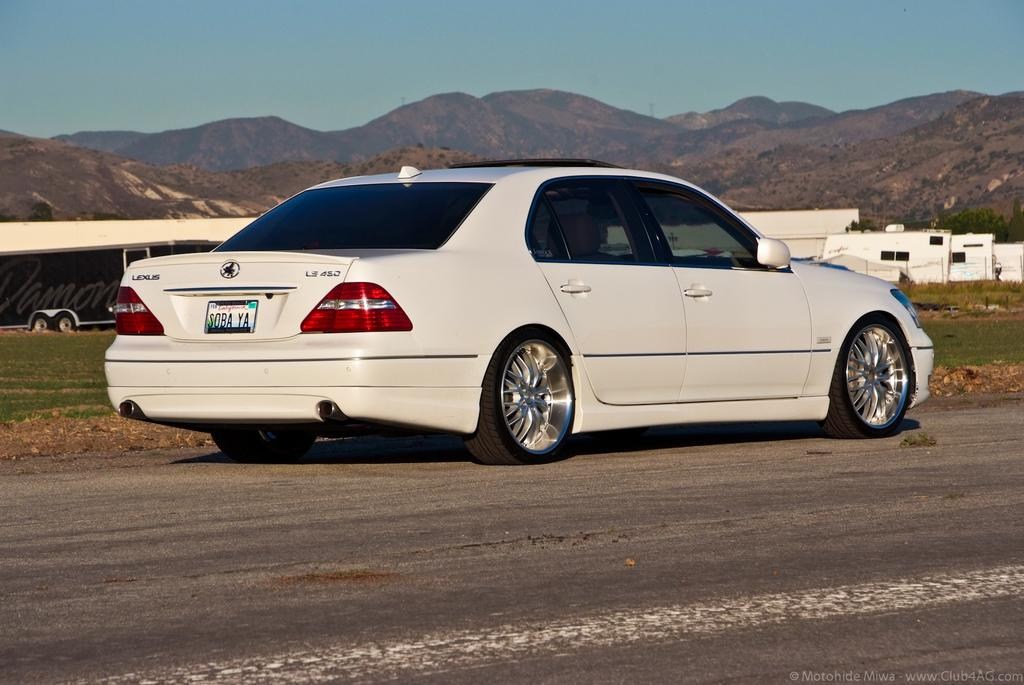What is on the road in the image? There is a vehicle on the road in the image. What type of vegetation can be seen in the image? There is grass visible in the image. What geographical features are present in the image? There are hills in the image. What is visible above the landscape in the image? The sky is visible in the image. What type of whip is being used by the driver in the image? There is no whip present in the image, and the driver is not using any whip to control the vehicle. 